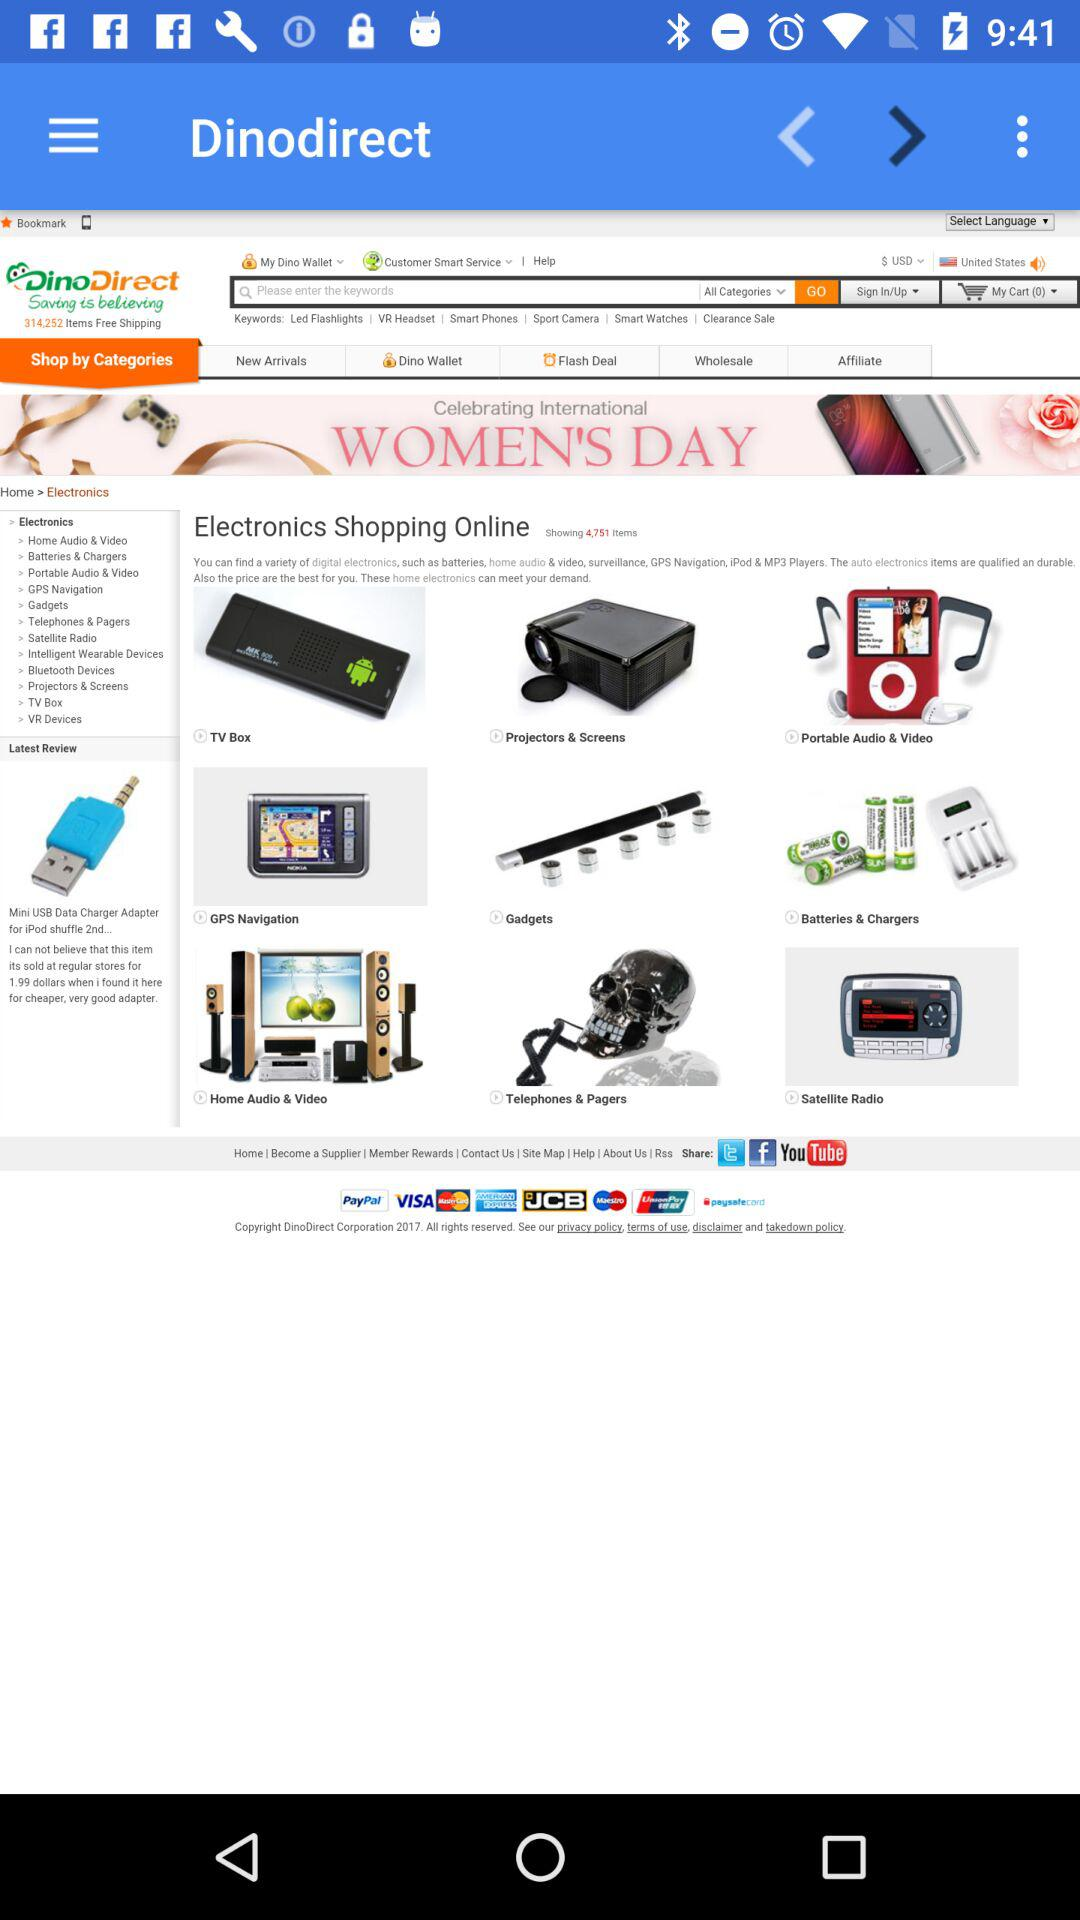What is the application name? The application name is "Dinodirect". 